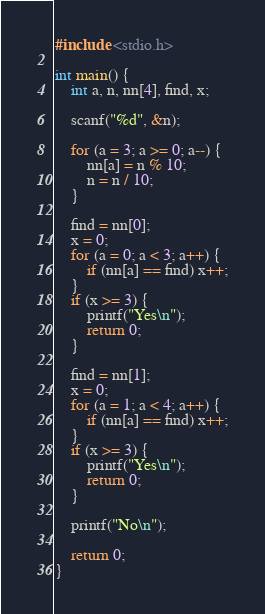<code> <loc_0><loc_0><loc_500><loc_500><_C++_>#include <stdio.h>

int main() {
	int a, n, nn[4], find, x;

	scanf("%d", &n);

	for (a = 3; a >= 0; a--) {
		nn[a] = n % 10;
		n = n / 10;
	}

	find = nn[0];
	x = 0;
	for (a = 0; a < 3; a++) {
		if (nn[a] == find) x++;
	}
	if (x >= 3) {
		printf("Yes\n");
		return 0;
	}

	find = nn[1];
	x = 0;
	for (a = 1; a < 4; a++) {
		if (nn[a] == find) x++;
	}
	if (x >= 3) {
		printf("Yes\n");
		return 0;
	}
	
	printf("No\n");

	return 0;
}</code> 